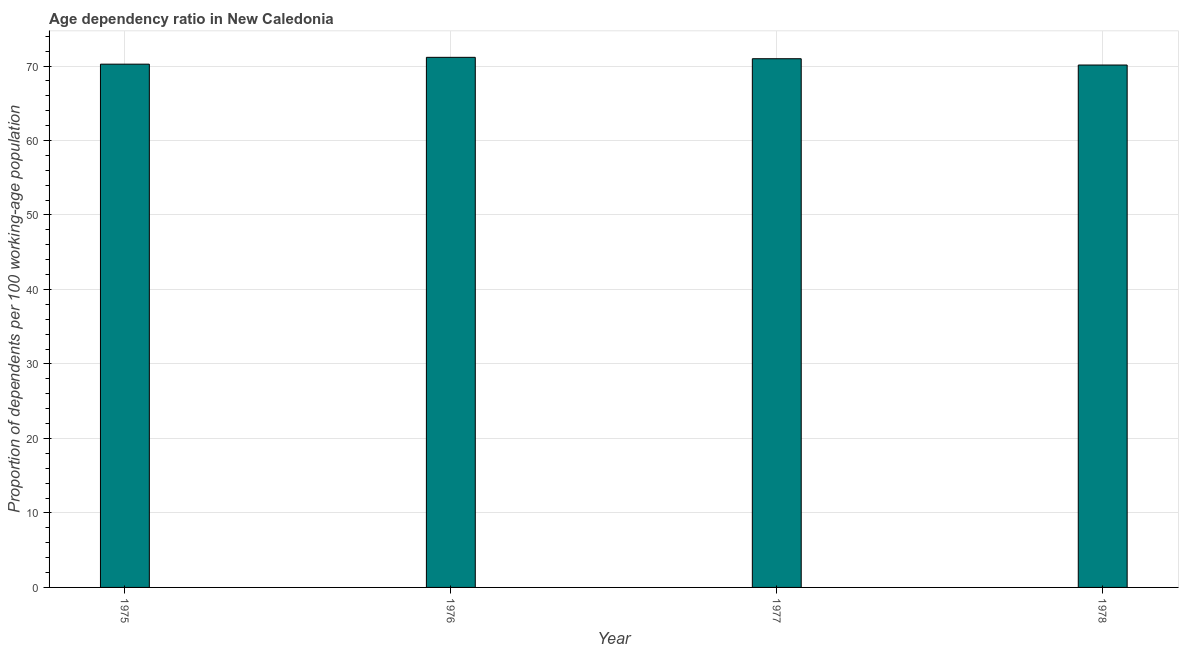Does the graph contain any zero values?
Provide a short and direct response. No. Does the graph contain grids?
Provide a succinct answer. Yes. What is the title of the graph?
Offer a terse response. Age dependency ratio in New Caledonia. What is the label or title of the X-axis?
Make the answer very short. Year. What is the label or title of the Y-axis?
Your answer should be very brief. Proportion of dependents per 100 working-age population. What is the age dependency ratio in 1975?
Offer a very short reply. 70.25. Across all years, what is the maximum age dependency ratio?
Give a very brief answer. 71.17. Across all years, what is the minimum age dependency ratio?
Offer a very short reply. 70.14. In which year was the age dependency ratio maximum?
Offer a very short reply. 1976. In which year was the age dependency ratio minimum?
Your response must be concise. 1978. What is the sum of the age dependency ratio?
Your answer should be very brief. 282.53. What is the difference between the age dependency ratio in 1975 and 1977?
Your answer should be very brief. -0.73. What is the average age dependency ratio per year?
Offer a very short reply. 70.63. What is the median age dependency ratio?
Keep it short and to the point. 70.62. In how many years, is the age dependency ratio greater than 38 ?
Ensure brevity in your answer.  4. Do a majority of the years between 1977 and 1975 (inclusive) have age dependency ratio greater than 30 ?
Keep it short and to the point. Yes. Is the difference between the age dependency ratio in 1976 and 1977 greater than the difference between any two years?
Your answer should be compact. No. What is the difference between the highest and the second highest age dependency ratio?
Provide a short and direct response. 0.19. What is the difference between the highest and the lowest age dependency ratio?
Keep it short and to the point. 1.03. How many bars are there?
Give a very brief answer. 4. How many years are there in the graph?
Offer a terse response. 4. What is the Proportion of dependents per 100 working-age population of 1975?
Give a very brief answer. 70.25. What is the Proportion of dependents per 100 working-age population of 1976?
Offer a terse response. 71.17. What is the Proportion of dependents per 100 working-age population in 1977?
Make the answer very short. 70.98. What is the Proportion of dependents per 100 working-age population of 1978?
Keep it short and to the point. 70.14. What is the difference between the Proportion of dependents per 100 working-age population in 1975 and 1976?
Keep it short and to the point. -0.92. What is the difference between the Proportion of dependents per 100 working-age population in 1975 and 1977?
Your answer should be compact. -0.73. What is the difference between the Proportion of dependents per 100 working-age population in 1975 and 1978?
Make the answer very short. 0.11. What is the difference between the Proportion of dependents per 100 working-age population in 1976 and 1977?
Offer a terse response. 0.19. What is the difference between the Proportion of dependents per 100 working-age population in 1976 and 1978?
Keep it short and to the point. 1.03. What is the difference between the Proportion of dependents per 100 working-age population in 1977 and 1978?
Your response must be concise. 0.84. What is the ratio of the Proportion of dependents per 100 working-age population in 1975 to that in 1976?
Provide a short and direct response. 0.99. What is the ratio of the Proportion of dependents per 100 working-age population in 1975 to that in 1977?
Offer a terse response. 0.99. What is the ratio of the Proportion of dependents per 100 working-age population in 1976 to that in 1977?
Ensure brevity in your answer.  1. 